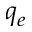<formula> <loc_0><loc_0><loc_500><loc_500>q _ { e }</formula> 